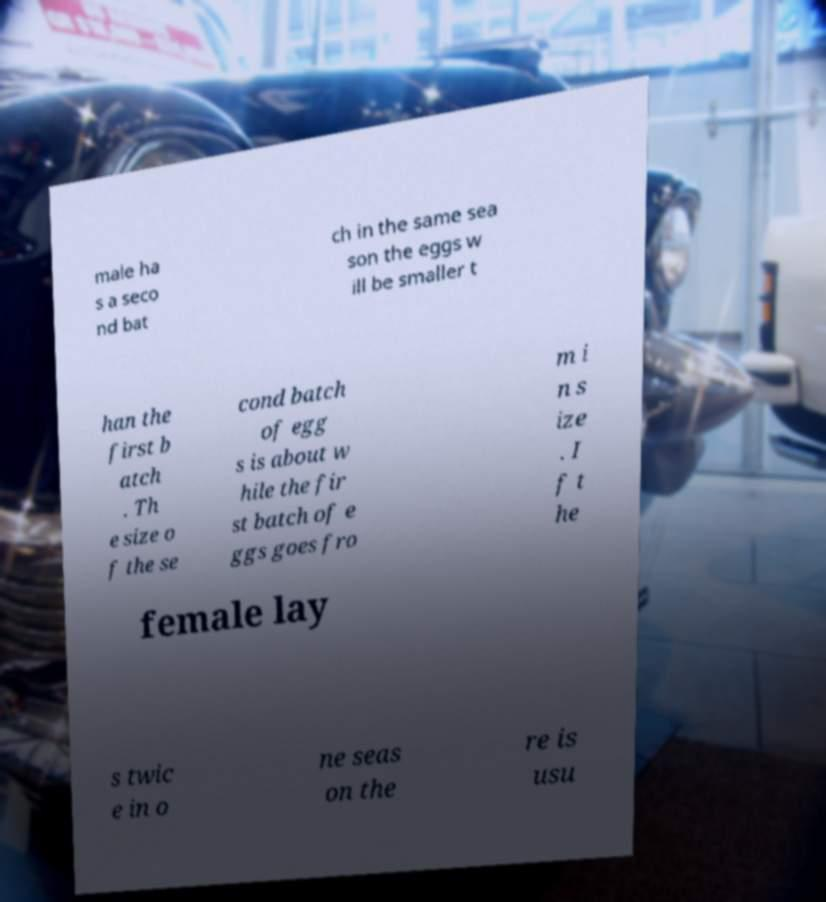Please identify and transcribe the text found in this image. male ha s a seco nd bat ch in the same sea son the eggs w ill be smaller t han the first b atch . Th e size o f the se cond batch of egg s is about w hile the fir st batch of e ggs goes fro m i n s ize . I f t he female lay s twic e in o ne seas on the re is usu 